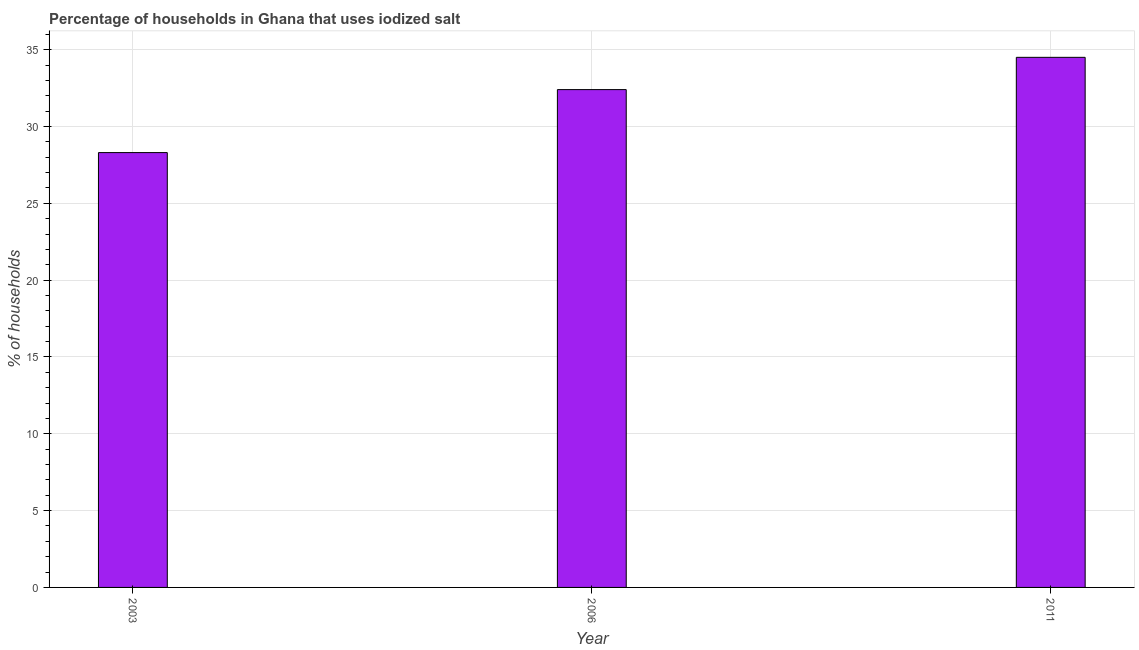What is the title of the graph?
Your answer should be very brief. Percentage of households in Ghana that uses iodized salt. What is the label or title of the Y-axis?
Ensure brevity in your answer.  % of households. What is the percentage of households where iodized salt is consumed in 2006?
Your answer should be compact. 32.4. Across all years, what is the maximum percentage of households where iodized salt is consumed?
Make the answer very short. 34.5. Across all years, what is the minimum percentage of households where iodized salt is consumed?
Ensure brevity in your answer.  28.3. In which year was the percentage of households where iodized salt is consumed minimum?
Your response must be concise. 2003. What is the sum of the percentage of households where iodized salt is consumed?
Your response must be concise. 95.2. What is the average percentage of households where iodized salt is consumed per year?
Keep it short and to the point. 31.73. What is the median percentage of households where iodized salt is consumed?
Your answer should be compact. 32.4. Do a majority of the years between 2003 and 2006 (inclusive) have percentage of households where iodized salt is consumed greater than 9 %?
Ensure brevity in your answer.  Yes. What is the ratio of the percentage of households where iodized salt is consumed in 2003 to that in 2011?
Provide a succinct answer. 0.82. Is the percentage of households where iodized salt is consumed in 2006 less than that in 2011?
Ensure brevity in your answer.  Yes. Is the difference between the percentage of households where iodized salt is consumed in 2006 and 2011 greater than the difference between any two years?
Ensure brevity in your answer.  No. What is the difference between the highest and the second highest percentage of households where iodized salt is consumed?
Offer a very short reply. 2.1. Is the sum of the percentage of households where iodized salt is consumed in 2006 and 2011 greater than the maximum percentage of households where iodized salt is consumed across all years?
Offer a very short reply. Yes. What is the difference between the highest and the lowest percentage of households where iodized salt is consumed?
Provide a short and direct response. 6.2. In how many years, is the percentage of households where iodized salt is consumed greater than the average percentage of households where iodized salt is consumed taken over all years?
Keep it short and to the point. 2. Are all the bars in the graph horizontal?
Provide a short and direct response. No. Are the values on the major ticks of Y-axis written in scientific E-notation?
Keep it short and to the point. No. What is the % of households in 2003?
Make the answer very short. 28.3. What is the % of households in 2006?
Offer a very short reply. 32.4. What is the % of households of 2011?
Your response must be concise. 34.5. What is the difference between the % of households in 2003 and 2006?
Keep it short and to the point. -4.1. What is the difference between the % of households in 2003 and 2011?
Provide a succinct answer. -6.2. What is the ratio of the % of households in 2003 to that in 2006?
Ensure brevity in your answer.  0.87. What is the ratio of the % of households in 2003 to that in 2011?
Your response must be concise. 0.82. What is the ratio of the % of households in 2006 to that in 2011?
Provide a short and direct response. 0.94. 